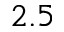Convert formula to latex. <formula><loc_0><loc_0><loc_500><loc_500>2 . 5</formula> 